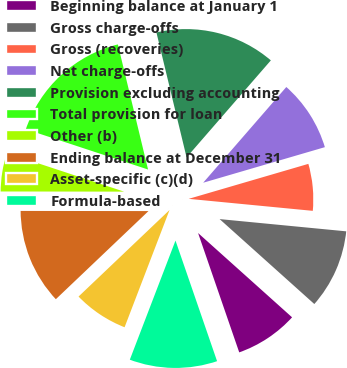Convert chart. <chart><loc_0><loc_0><loc_500><loc_500><pie_chart><fcel>Beginning balance at January 1<fcel>Gross charge-offs<fcel>Gross (recoveries)<fcel>Net charge-offs<fcel>Provision excluding accounting<fcel>Total provision for loan<fcel>Other (b)<fcel>Ending balance at December 31<fcel>Asset-specific (c)(d)<fcel>Formula-based<nl><fcel>8.08%<fcel>10.1%<fcel>6.06%<fcel>9.09%<fcel>15.15%<fcel>16.16%<fcel>5.05%<fcel>12.12%<fcel>7.07%<fcel>11.11%<nl></chart> 